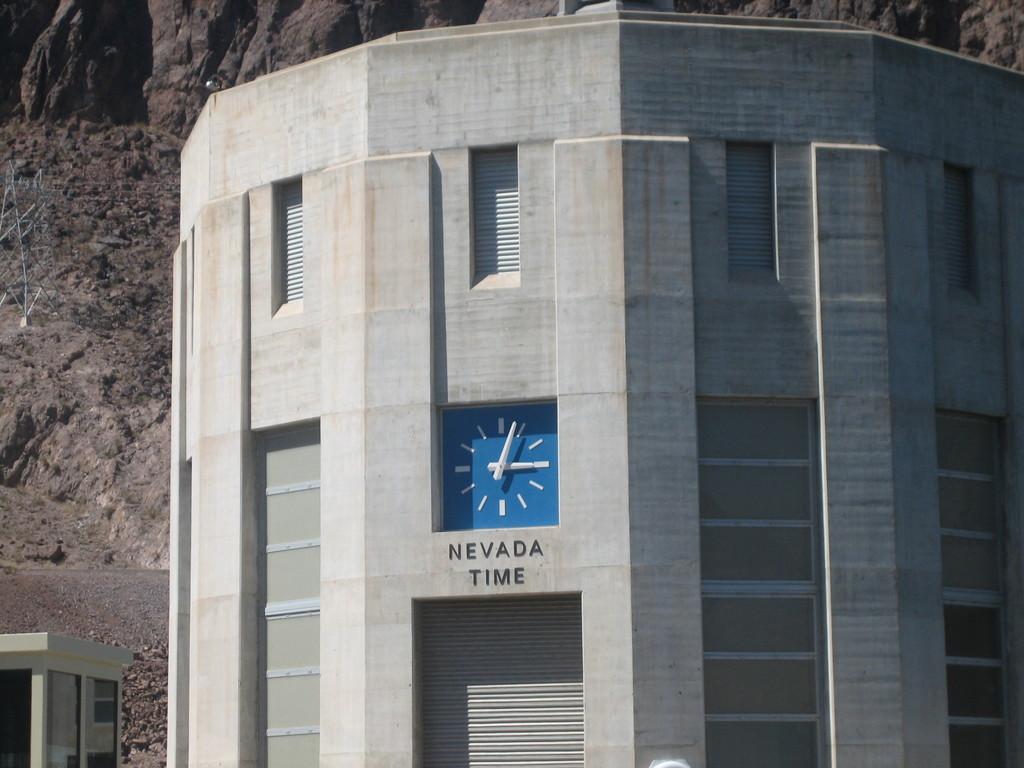Is this the time in nevada?
Give a very brief answer. Yes. Of what state the clock show the time?
Keep it short and to the point. Nevada. 